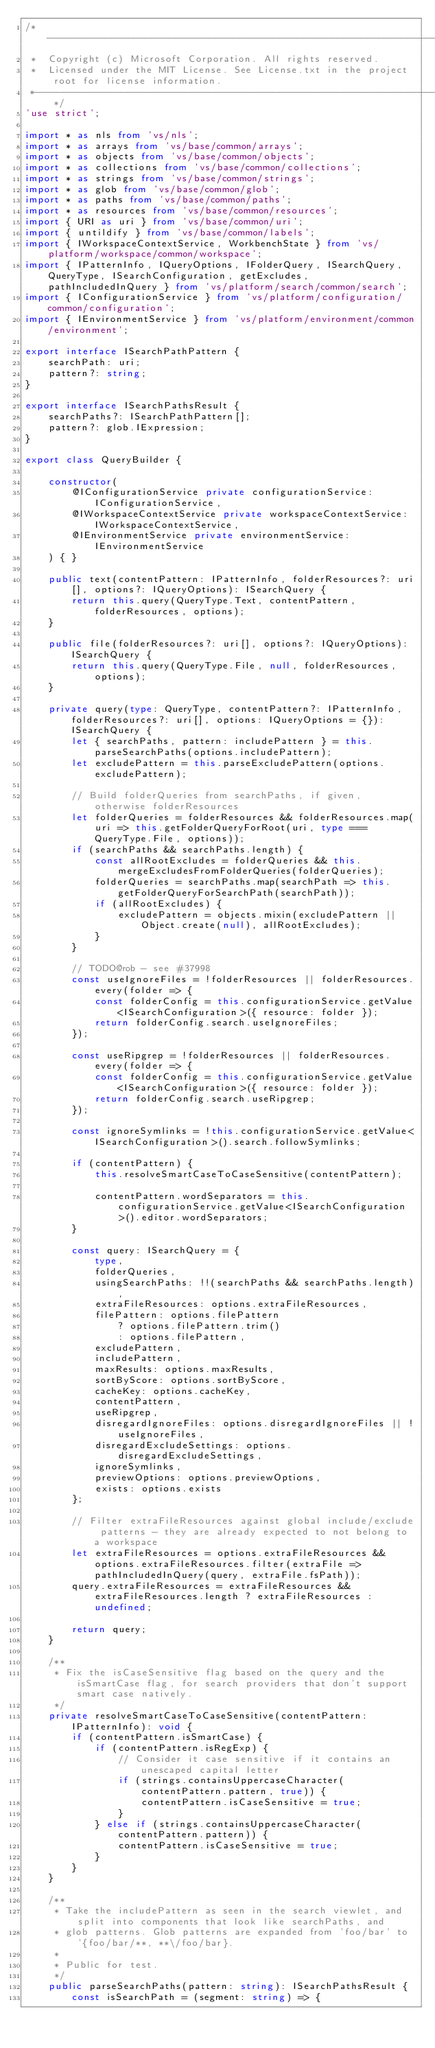Convert code to text. <code><loc_0><loc_0><loc_500><loc_500><_TypeScript_>/*---------------------------------------------------------------------------------------------
 *  Copyright (c) Microsoft Corporation. All rights reserved.
 *  Licensed under the MIT License. See License.txt in the project root for license information.
 *--------------------------------------------------------------------------------------------*/
'use strict';

import * as nls from 'vs/nls';
import * as arrays from 'vs/base/common/arrays';
import * as objects from 'vs/base/common/objects';
import * as collections from 'vs/base/common/collections';
import * as strings from 'vs/base/common/strings';
import * as glob from 'vs/base/common/glob';
import * as paths from 'vs/base/common/paths';
import * as resources from 'vs/base/common/resources';
import { URI as uri } from 'vs/base/common/uri';
import { untildify } from 'vs/base/common/labels';
import { IWorkspaceContextService, WorkbenchState } from 'vs/platform/workspace/common/workspace';
import { IPatternInfo, IQueryOptions, IFolderQuery, ISearchQuery, QueryType, ISearchConfiguration, getExcludes, pathIncludedInQuery } from 'vs/platform/search/common/search';
import { IConfigurationService } from 'vs/platform/configuration/common/configuration';
import { IEnvironmentService } from 'vs/platform/environment/common/environment';

export interface ISearchPathPattern {
	searchPath: uri;
	pattern?: string;
}

export interface ISearchPathsResult {
	searchPaths?: ISearchPathPattern[];
	pattern?: glob.IExpression;
}

export class QueryBuilder {

	constructor(
		@IConfigurationService private configurationService: IConfigurationService,
		@IWorkspaceContextService private workspaceContextService: IWorkspaceContextService,
		@IEnvironmentService private environmentService: IEnvironmentService
	) { }

	public text(contentPattern: IPatternInfo, folderResources?: uri[], options?: IQueryOptions): ISearchQuery {
		return this.query(QueryType.Text, contentPattern, folderResources, options);
	}

	public file(folderResources?: uri[], options?: IQueryOptions): ISearchQuery {
		return this.query(QueryType.File, null, folderResources, options);
	}

	private query(type: QueryType, contentPattern?: IPatternInfo, folderResources?: uri[], options: IQueryOptions = {}): ISearchQuery {
		let { searchPaths, pattern: includePattern } = this.parseSearchPaths(options.includePattern);
		let excludePattern = this.parseExcludePattern(options.excludePattern);

		// Build folderQueries from searchPaths, if given, otherwise folderResources
		let folderQueries = folderResources && folderResources.map(uri => this.getFolderQueryForRoot(uri, type === QueryType.File, options));
		if (searchPaths && searchPaths.length) {
			const allRootExcludes = folderQueries && this.mergeExcludesFromFolderQueries(folderQueries);
			folderQueries = searchPaths.map(searchPath => this.getFolderQueryForSearchPath(searchPath));
			if (allRootExcludes) {
				excludePattern = objects.mixin(excludePattern || Object.create(null), allRootExcludes);
			}
		}

		// TODO@rob - see #37998
		const useIgnoreFiles = !folderResources || folderResources.every(folder => {
			const folderConfig = this.configurationService.getValue<ISearchConfiguration>({ resource: folder });
			return folderConfig.search.useIgnoreFiles;
		});

		const useRipgrep = !folderResources || folderResources.every(folder => {
			const folderConfig = this.configurationService.getValue<ISearchConfiguration>({ resource: folder });
			return folderConfig.search.useRipgrep;
		});

		const ignoreSymlinks = !this.configurationService.getValue<ISearchConfiguration>().search.followSymlinks;

		if (contentPattern) {
			this.resolveSmartCaseToCaseSensitive(contentPattern);

			contentPattern.wordSeparators = this.configurationService.getValue<ISearchConfiguration>().editor.wordSeparators;
		}

		const query: ISearchQuery = {
			type,
			folderQueries,
			usingSearchPaths: !!(searchPaths && searchPaths.length),
			extraFileResources: options.extraFileResources,
			filePattern: options.filePattern
				? options.filePattern.trim()
				: options.filePattern,
			excludePattern,
			includePattern,
			maxResults: options.maxResults,
			sortByScore: options.sortByScore,
			cacheKey: options.cacheKey,
			contentPattern,
			useRipgrep,
			disregardIgnoreFiles: options.disregardIgnoreFiles || !useIgnoreFiles,
			disregardExcludeSettings: options.disregardExcludeSettings,
			ignoreSymlinks,
			previewOptions: options.previewOptions,
			exists: options.exists
		};

		// Filter extraFileResources against global include/exclude patterns - they are already expected to not belong to a workspace
		let extraFileResources = options.extraFileResources && options.extraFileResources.filter(extraFile => pathIncludedInQuery(query, extraFile.fsPath));
		query.extraFileResources = extraFileResources && extraFileResources.length ? extraFileResources : undefined;

		return query;
	}

	/**
	 * Fix the isCaseSensitive flag based on the query and the isSmartCase flag, for search providers that don't support smart case natively.
	 */
	private resolveSmartCaseToCaseSensitive(contentPattern: IPatternInfo): void {
		if (contentPattern.isSmartCase) {
			if (contentPattern.isRegExp) {
				// Consider it case sensitive if it contains an unescaped capital letter
				if (strings.containsUppercaseCharacter(contentPattern.pattern, true)) {
					contentPattern.isCaseSensitive = true;
				}
			} else if (strings.containsUppercaseCharacter(contentPattern.pattern)) {
				contentPattern.isCaseSensitive = true;
			}
		}
	}

	/**
	 * Take the includePattern as seen in the search viewlet, and split into components that look like searchPaths, and
	 * glob patterns. Glob patterns are expanded from 'foo/bar' to '{foo/bar/**, **\/foo/bar}.
	 *
	 * Public for test.
	 */
	public parseSearchPaths(pattern: string): ISearchPathsResult {
		const isSearchPath = (segment: string) => {</code> 